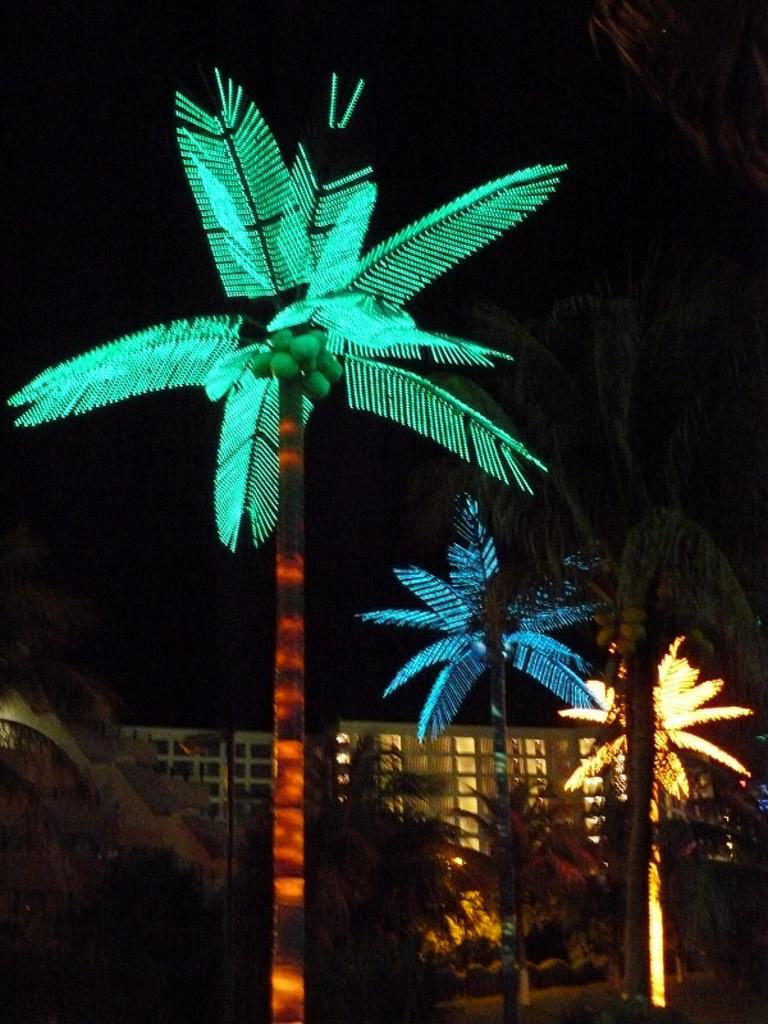Please provide a concise description of this image. In this picture we can see trees in the front, in the background there is a building, we can see a dark background. 